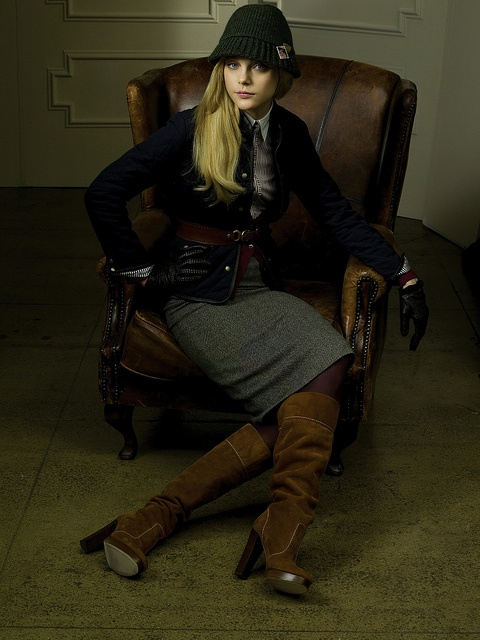Describe the objects in this image and their specific colors. I can see people in black, darkgreen, and gray tones, chair in black, maroon, and gray tones, handbag in black, darkgreen, gray, and olive tones, and tie in black, darkgreen, and gray tones in this image. 